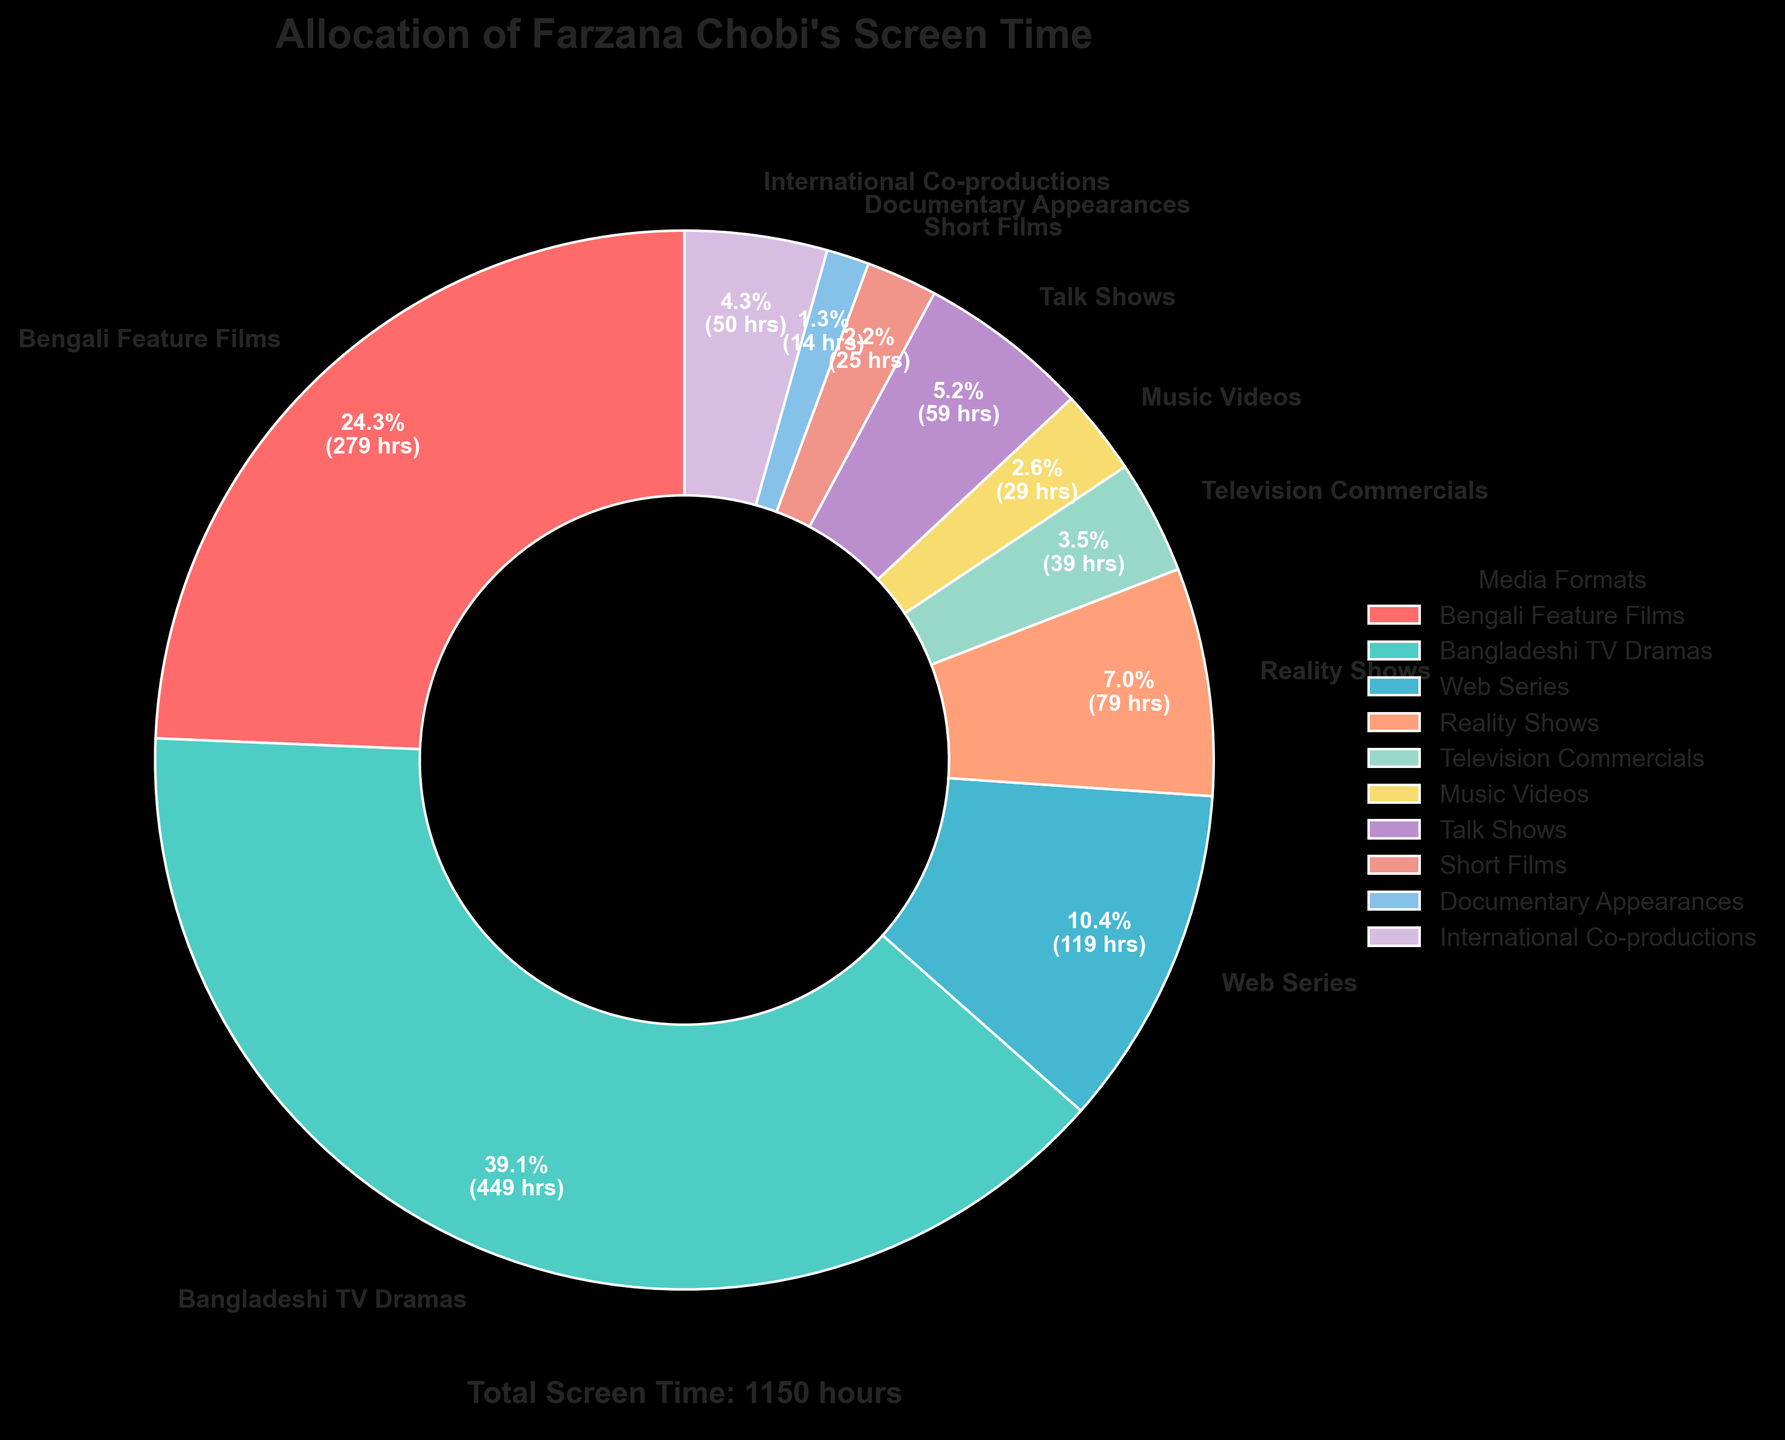Which media format occupies the largest portion of Farzana Chobi's screen time? By looking at the pie chart, identify the segment with the largest area. Bengali Feature Films is a large area but Bangladeshi TV Dramas covers the largest portion with 450 hours.
Answer: Bangladeshi TV Dramas How many hours less has Farzana Chobi spent on music videos compared to talk shows? Find the segments for Music Videos and Talk Shows. Subtract the hours of Music Videos (30) from Talk Shows (60). The difference is 60 - 30 = 30 hours.
Answer: 30 hours What's the sum of Farzana Chobi's screen time in short films and documentary appearances? Locate both Short Films and Documentary Appearances in the chart. Add their hours: 25 (Short Films) + 15 (Documentary Appearances) = 40.
Answer: 40 hours Which two media formats combined make up 80 hours of Farzana Chobi's screen time? From the chart, look for two segments that together total 80 hours. Here, Reality Shows and Television Commercials both total: 80 (Reality Shows) + 40 (Television Commercials) = 80 hours.
Answer: Reality Shows and Television Commercials Which media format uses the red color in the pie chart? Identify the segment in red color. According to the chart, Bengali Feature Films is represented in red.
Answer: Bengali Feature Films How much more time has Farzana Chobi spent in TV Dramas compared to International Co-productions? Compare Bangladeshi TV Dramas (450 hours) to International Co-productions (50 hours). Calculate 450 - 50 = 400 hours.
Answer: 400 hours What's the percentage of Farzana Chobi's screen time allocated to web series? Calculate the percentage by locating the Web Series segment, which is labeled in the chart as 120 hours. The total screen time is 1150 hours. The percentage is (120 / 1150) * 100 ≈ 10.4%.
Answer: 10.4% What's the total screen time occupied by Reality Shows, Music Videos, and Talk Shows combined? Find the screen time for Reality Shows (80), Music Videos (30), and Talk Shows (60), then add them: 80 + 30 + 60 = 170 hours.
Answer: 170 hours Which has a smaller portion on the pie chart: Short Films or Web Series? Visually compare the segments for Short Films (25 hours) and Web Series (120 hours). Short Films have a smaller portion.
Answer: Short Films Is the screen time spent on Talk Shows greater than the screen time on Music Videos and Documentary Appearances combined? Calculate the combined hours of Music Videos (30) and Documentary Appearances (15) = 45. Compare this to Talk Shows (60 hours). 60 is greater than 45.
Answer: Yes 